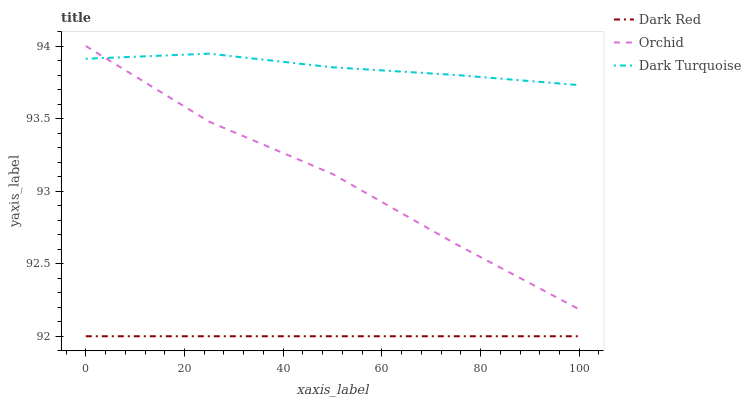Does Dark Red have the minimum area under the curve?
Answer yes or no. Yes. Does Dark Turquoise have the maximum area under the curve?
Answer yes or no. Yes. Does Orchid have the minimum area under the curve?
Answer yes or no. No. Does Orchid have the maximum area under the curve?
Answer yes or no. No. Is Dark Red the smoothest?
Answer yes or no. Yes. Is Orchid the roughest?
Answer yes or no. Yes. Is Dark Turquoise the smoothest?
Answer yes or no. No. Is Dark Turquoise the roughest?
Answer yes or no. No. Does Dark Red have the lowest value?
Answer yes or no. Yes. Does Orchid have the lowest value?
Answer yes or no. No. Does Orchid have the highest value?
Answer yes or no. Yes. Does Dark Turquoise have the highest value?
Answer yes or no. No. Is Dark Red less than Orchid?
Answer yes or no. Yes. Is Dark Turquoise greater than Dark Red?
Answer yes or no. Yes. Does Orchid intersect Dark Turquoise?
Answer yes or no. Yes. Is Orchid less than Dark Turquoise?
Answer yes or no. No. Is Orchid greater than Dark Turquoise?
Answer yes or no. No. Does Dark Red intersect Orchid?
Answer yes or no. No. 